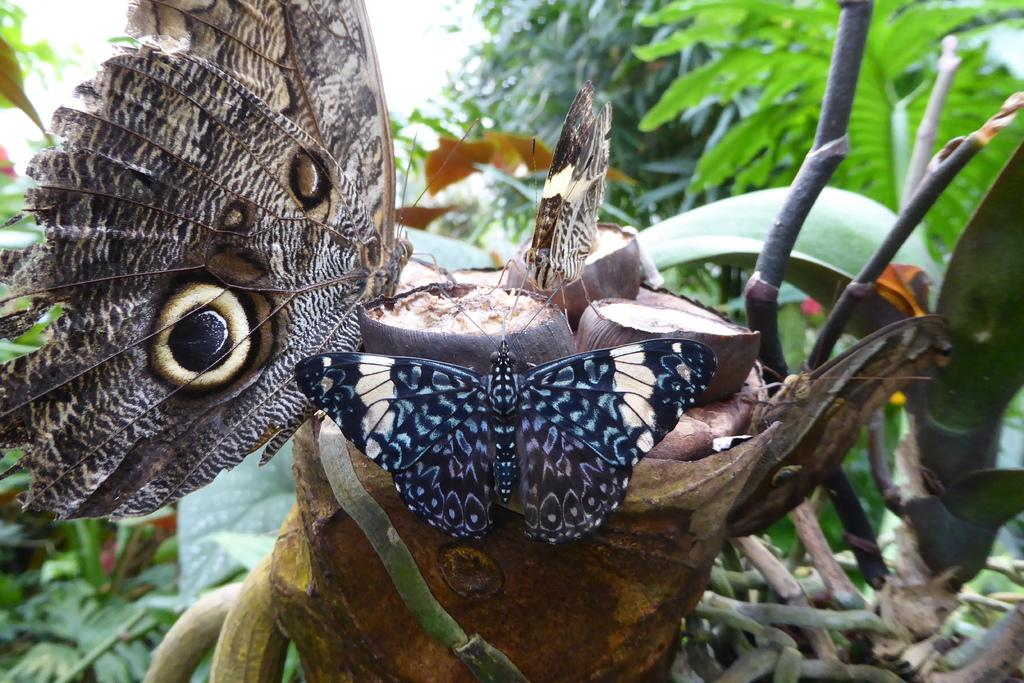What type of animals can be seen on the plant in the image? There are butterflies on a plant in the image. What can be seen in the background of the image? There are trees visible in the background of the image. What type of building can be seen in the image? There is no building present in the image; it features butterflies on a plant and trees in the background. 